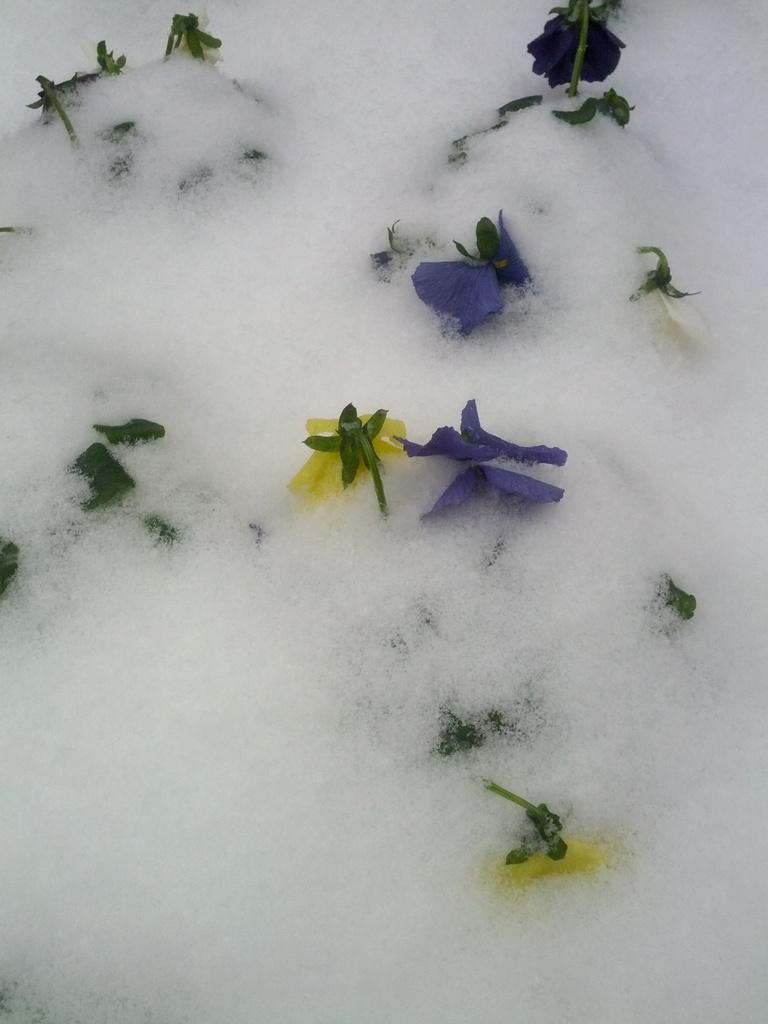In one or two sentences, can you explain what this image depicts? In this image we can see flowers in the foam. 